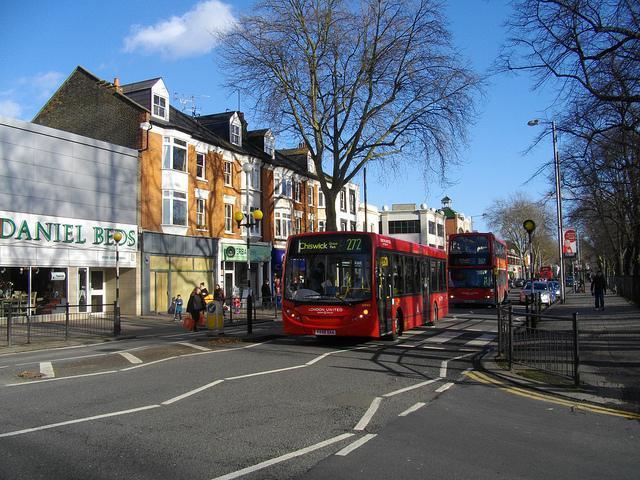What season is it in the image?
Pick the right solution, then justify: 'Answer: answer
Rationale: rationale.'
Options: Spring, summer, spring-summer, fall-winter. Answer: fall-winter.
Rationale: There are no leaves on the trees. 